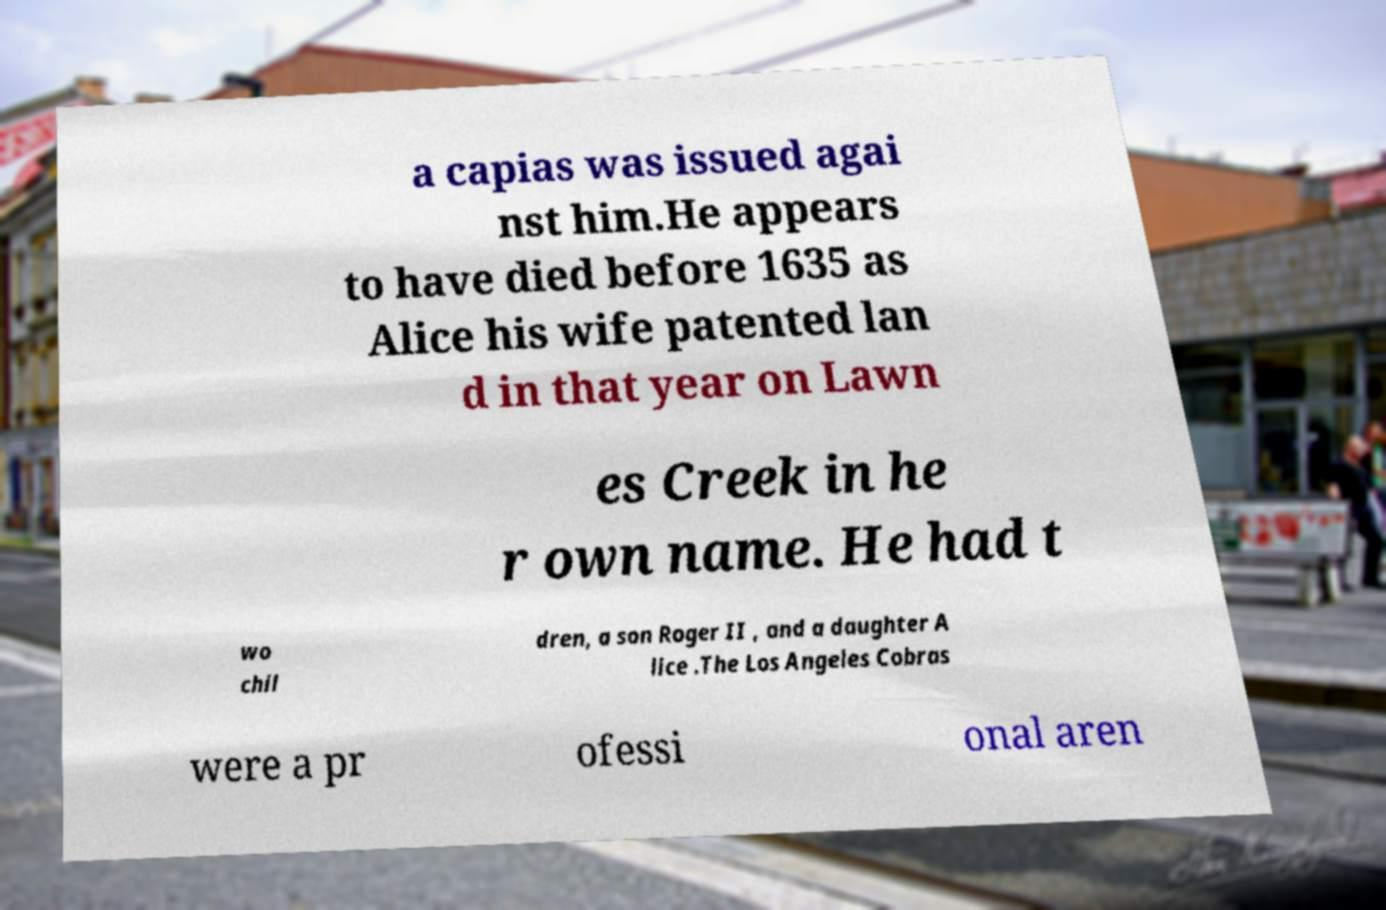Can you accurately transcribe the text from the provided image for me? a capias was issued agai nst him.He appears to have died before 1635 as Alice his wife patented lan d in that year on Lawn es Creek in he r own name. He had t wo chil dren, a son Roger II , and a daughter A lice .The Los Angeles Cobras were a pr ofessi onal aren 